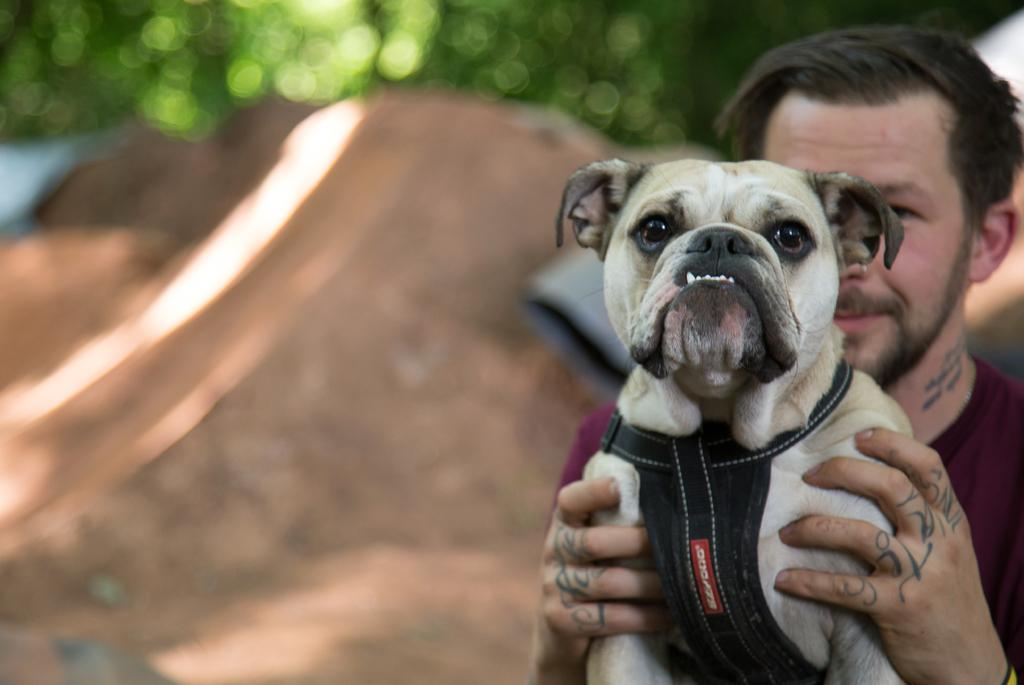What type of animal can be seen in the image? There is a dog in the image. Where is the dog located in the image? The dog is on the right side of the image. Who is holding the dog in the image? The man is holding the dog in the image. What is the man wearing in the image? The man is wearing a maroon dress in the image. Where are the man and the dog located in the image? The man and the dog are on the top right side of the image. What type of ground is visible in the image? There is soil in the image. Where is the soil located in the image? The soil is on the left side of the image. What can be seen in the background of the image? There is greenery in the background of the image. What type of pan is being used to cook the goat in the image? There is no pan or goat present in the image. 